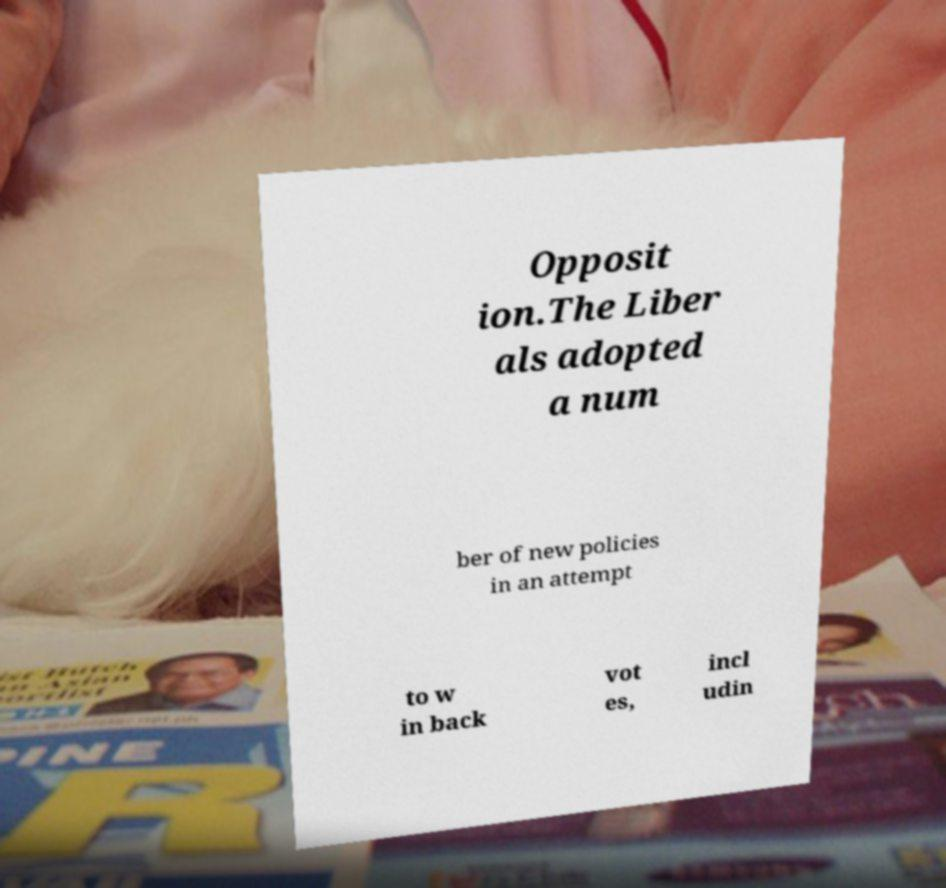Could you assist in decoding the text presented in this image and type it out clearly? Opposit ion.The Liber als adopted a num ber of new policies in an attempt to w in back vot es, incl udin 